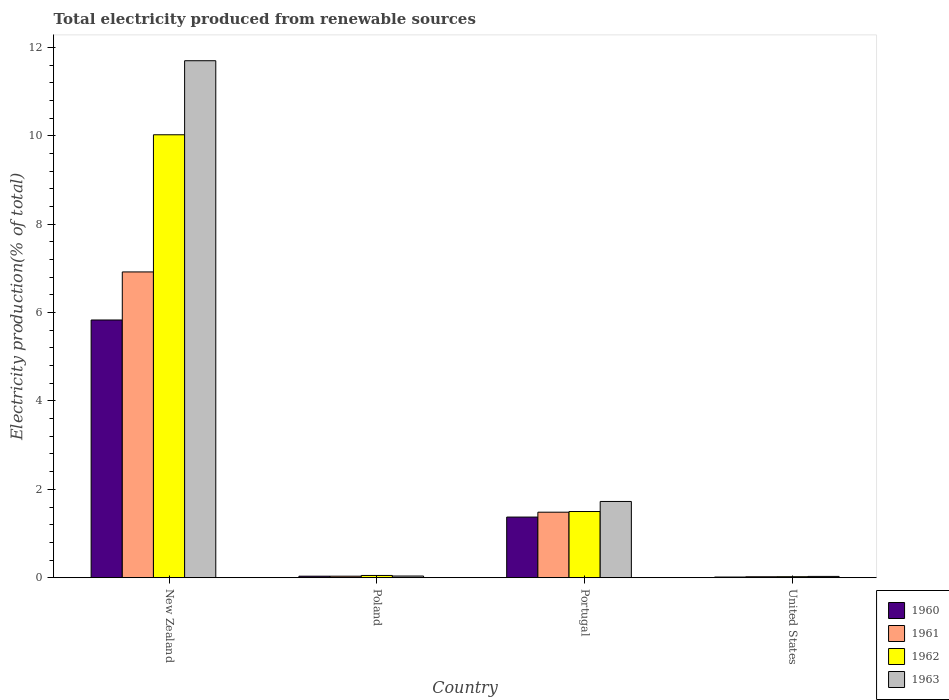How many groups of bars are there?
Offer a terse response. 4. Are the number of bars per tick equal to the number of legend labels?
Ensure brevity in your answer.  Yes. Are the number of bars on each tick of the X-axis equal?
Keep it short and to the point. Yes. How many bars are there on the 3rd tick from the left?
Provide a succinct answer. 4. How many bars are there on the 4th tick from the right?
Keep it short and to the point. 4. What is the label of the 1st group of bars from the left?
Make the answer very short. New Zealand. In how many cases, is the number of bars for a given country not equal to the number of legend labels?
Make the answer very short. 0. What is the total electricity produced in 1963 in Poland?
Your answer should be compact. 0.04. Across all countries, what is the maximum total electricity produced in 1961?
Offer a very short reply. 6.92. Across all countries, what is the minimum total electricity produced in 1962?
Give a very brief answer. 0.02. In which country was the total electricity produced in 1963 maximum?
Offer a terse response. New Zealand. What is the total total electricity produced in 1963 in the graph?
Offer a very short reply. 13.49. What is the difference between the total electricity produced in 1963 in New Zealand and that in Portugal?
Your answer should be compact. 9.97. What is the difference between the total electricity produced in 1961 in Poland and the total electricity produced in 1960 in Portugal?
Keep it short and to the point. -1.34. What is the average total electricity produced in 1963 per country?
Give a very brief answer. 3.37. What is the difference between the total electricity produced of/in 1962 and total electricity produced of/in 1960 in New Zealand?
Make the answer very short. 4.19. What is the ratio of the total electricity produced in 1960 in New Zealand to that in Portugal?
Provide a short and direct response. 4.25. Is the difference between the total electricity produced in 1962 in Portugal and United States greater than the difference between the total electricity produced in 1960 in Portugal and United States?
Ensure brevity in your answer.  Yes. What is the difference between the highest and the second highest total electricity produced in 1960?
Give a very brief answer. -1.34. What is the difference between the highest and the lowest total electricity produced in 1960?
Offer a very short reply. 5.82. In how many countries, is the total electricity produced in 1963 greater than the average total electricity produced in 1963 taken over all countries?
Keep it short and to the point. 1. Is the sum of the total electricity produced in 1960 in New Zealand and United States greater than the maximum total electricity produced in 1961 across all countries?
Your answer should be very brief. No. What does the 4th bar from the right in Poland represents?
Offer a terse response. 1960. Does the graph contain any zero values?
Your response must be concise. No. Does the graph contain grids?
Your response must be concise. No. What is the title of the graph?
Your answer should be compact. Total electricity produced from renewable sources. What is the label or title of the X-axis?
Your response must be concise. Country. What is the Electricity production(% of total) in 1960 in New Zealand?
Keep it short and to the point. 5.83. What is the Electricity production(% of total) of 1961 in New Zealand?
Your answer should be compact. 6.92. What is the Electricity production(% of total) in 1962 in New Zealand?
Your answer should be very brief. 10.02. What is the Electricity production(% of total) in 1963 in New Zealand?
Your answer should be compact. 11.7. What is the Electricity production(% of total) of 1960 in Poland?
Give a very brief answer. 0.03. What is the Electricity production(% of total) in 1961 in Poland?
Provide a succinct answer. 0.03. What is the Electricity production(% of total) of 1962 in Poland?
Provide a short and direct response. 0.05. What is the Electricity production(% of total) in 1963 in Poland?
Provide a short and direct response. 0.04. What is the Electricity production(% of total) in 1960 in Portugal?
Offer a very short reply. 1.37. What is the Electricity production(% of total) of 1961 in Portugal?
Provide a short and direct response. 1.48. What is the Electricity production(% of total) in 1962 in Portugal?
Keep it short and to the point. 1.5. What is the Electricity production(% of total) in 1963 in Portugal?
Make the answer very short. 1.73. What is the Electricity production(% of total) in 1960 in United States?
Ensure brevity in your answer.  0.02. What is the Electricity production(% of total) of 1961 in United States?
Your answer should be compact. 0.02. What is the Electricity production(% of total) in 1962 in United States?
Your response must be concise. 0.02. What is the Electricity production(% of total) of 1963 in United States?
Ensure brevity in your answer.  0.03. Across all countries, what is the maximum Electricity production(% of total) in 1960?
Your answer should be compact. 5.83. Across all countries, what is the maximum Electricity production(% of total) in 1961?
Offer a terse response. 6.92. Across all countries, what is the maximum Electricity production(% of total) in 1962?
Offer a terse response. 10.02. Across all countries, what is the maximum Electricity production(% of total) in 1963?
Make the answer very short. 11.7. Across all countries, what is the minimum Electricity production(% of total) in 1960?
Give a very brief answer. 0.02. Across all countries, what is the minimum Electricity production(% of total) of 1961?
Give a very brief answer. 0.02. Across all countries, what is the minimum Electricity production(% of total) in 1962?
Offer a terse response. 0.02. Across all countries, what is the minimum Electricity production(% of total) of 1963?
Your answer should be very brief. 0.03. What is the total Electricity production(% of total) in 1960 in the graph?
Make the answer very short. 7.25. What is the total Electricity production(% of total) in 1961 in the graph?
Ensure brevity in your answer.  8.46. What is the total Electricity production(% of total) in 1962 in the graph?
Keep it short and to the point. 11.6. What is the total Electricity production(% of total) in 1963 in the graph?
Offer a very short reply. 13.49. What is the difference between the Electricity production(% of total) in 1960 in New Zealand and that in Poland?
Your response must be concise. 5.8. What is the difference between the Electricity production(% of total) in 1961 in New Zealand and that in Poland?
Give a very brief answer. 6.89. What is the difference between the Electricity production(% of total) in 1962 in New Zealand and that in Poland?
Your answer should be compact. 9.97. What is the difference between the Electricity production(% of total) of 1963 in New Zealand and that in Poland?
Ensure brevity in your answer.  11.66. What is the difference between the Electricity production(% of total) of 1960 in New Zealand and that in Portugal?
Provide a succinct answer. 4.46. What is the difference between the Electricity production(% of total) in 1961 in New Zealand and that in Portugal?
Keep it short and to the point. 5.44. What is the difference between the Electricity production(% of total) of 1962 in New Zealand and that in Portugal?
Your response must be concise. 8.53. What is the difference between the Electricity production(% of total) of 1963 in New Zealand and that in Portugal?
Keep it short and to the point. 9.97. What is the difference between the Electricity production(% of total) in 1960 in New Zealand and that in United States?
Give a very brief answer. 5.82. What is the difference between the Electricity production(% of total) in 1961 in New Zealand and that in United States?
Your answer should be very brief. 6.9. What is the difference between the Electricity production(% of total) of 1962 in New Zealand and that in United States?
Provide a succinct answer. 10. What is the difference between the Electricity production(% of total) in 1963 in New Zealand and that in United States?
Make the answer very short. 11.67. What is the difference between the Electricity production(% of total) in 1960 in Poland and that in Portugal?
Provide a short and direct response. -1.34. What is the difference between the Electricity production(% of total) in 1961 in Poland and that in Portugal?
Provide a succinct answer. -1.45. What is the difference between the Electricity production(% of total) in 1962 in Poland and that in Portugal?
Offer a terse response. -1.45. What is the difference between the Electricity production(% of total) of 1963 in Poland and that in Portugal?
Provide a short and direct response. -1.69. What is the difference between the Electricity production(% of total) of 1960 in Poland and that in United States?
Your response must be concise. 0.02. What is the difference between the Electricity production(% of total) of 1961 in Poland and that in United States?
Ensure brevity in your answer.  0.01. What is the difference between the Electricity production(% of total) of 1962 in Poland and that in United States?
Your answer should be very brief. 0.03. What is the difference between the Electricity production(% of total) of 1963 in Poland and that in United States?
Provide a short and direct response. 0.01. What is the difference between the Electricity production(% of total) in 1960 in Portugal and that in United States?
Keep it short and to the point. 1.36. What is the difference between the Electricity production(% of total) in 1961 in Portugal and that in United States?
Your answer should be compact. 1.46. What is the difference between the Electricity production(% of total) in 1962 in Portugal and that in United States?
Make the answer very short. 1.48. What is the difference between the Electricity production(% of total) in 1963 in Portugal and that in United States?
Offer a terse response. 1.7. What is the difference between the Electricity production(% of total) of 1960 in New Zealand and the Electricity production(% of total) of 1961 in Poland?
Give a very brief answer. 5.8. What is the difference between the Electricity production(% of total) of 1960 in New Zealand and the Electricity production(% of total) of 1962 in Poland?
Make the answer very short. 5.78. What is the difference between the Electricity production(% of total) of 1960 in New Zealand and the Electricity production(% of total) of 1963 in Poland?
Offer a terse response. 5.79. What is the difference between the Electricity production(% of total) of 1961 in New Zealand and the Electricity production(% of total) of 1962 in Poland?
Provide a succinct answer. 6.87. What is the difference between the Electricity production(% of total) of 1961 in New Zealand and the Electricity production(% of total) of 1963 in Poland?
Keep it short and to the point. 6.88. What is the difference between the Electricity production(% of total) in 1962 in New Zealand and the Electricity production(% of total) in 1963 in Poland?
Ensure brevity in your answer.  9.99. What is the difference between the Electricity production(% of total) of 1960 in New Zealand and the Electricity production(% of total) of 1961 in Portugal?
Your answer should be compact. 4.35. What is the difference between the Electricity production(% of total) of 1960 in New Zealand and the Electricity production(% of total) of 1962 in Portugal?
Make the answer very short. 4.33. What is the difference between the Electricity production(% of total) in 1960 in New Zealand and the Electricity production(% of total) in 1963 in Portugal?
Provide a succinct answer. 4.11. What is the difference between the Electricity production(% of total) in 1961 in New Zealand and the Electricity production(% of total) in 1962 in Portugal?
Ensure brevity in your answer.  5.42. What is the difference between the Electricity production(% of total) of 1961 in New Zealand and the Electricity production(% of total) of 1963 in Portugal?
Your answer should be very brief. 5.19. What is the difference between the Electricity production(% of total) in 1962 in New Zealand and the Electricity production(% of total) in 1963 in Portugal?
Ensure brevity in your answer.  8.3. What is the difference between the Electricity production(% of total) of 1960 in New Zealand and the Electricity production(% of total) of 1961 in United States?
Offer a very short reply. 5.81. What is the difference between the Electricity production(% of total) in 1960 in New Zealand and the Electricity production(% of total) in 1962 in United States?
Give a very brief answer. 5.81. What is the difference between the Electricity production(% of total) in 1960 in New Zealand and the Electricity production(% of total) in 1963 in United States?
Provide a short and direct response. 5.8. What is the difference between the Electricity production(% of total) in 1961 in New Zealand and the Electricity production(% of total) in 1962 in United States?
Ensure brevity in your answer.  6.9. What is the difference between the Electricity production(% of total) of 1961 in New Zealand and the Electricity production(% of total) of 1963 in United States?
Offer a very short reply. 6.89. What is the difference between the Electricity production(% of total) of 1962 in New Zealand and the Electricity production(% of total) of 1963 in United States?
Your response must be concise. 10. What is the difference between the Electricity production(% of total) in 1960 in Poland and the Electricity production(% of total) in 1961 in Portugal?
Your answer should be very brief. -1.45. What is the difference between the Electricity production(% of total) of 1960 in Poland and the Electricity production(% of total) of 1962 in Portugal?
Your answer should be compact. -1.46. What is the difference between the Electricity production(% of total) of 1960 in Poland and the Electricity production(% of total) of 1963 in Portugal?
Provide a short and direct response. -1.69. What is the difference between the Electricity production(% of total) of 1961 in Poland and the Electricity production(% of total) of 1962 in Portugal?
Make the answer very short. -1.46. What is the difference between the Electricity production(% of total) of 1961 in Poland and the Electricity production(% of total) of 1963 in Portugal?
Ensure brevity in your answer.  -1.69. What is the difference between the Electricity production(% of total) in 1962 in Poland and the Electricity production(% of total) in 1963 in Portugal?
Provide a succinct answer. -1.67. What is the difference between the Electricity production(% of total) of 1960 in Poland and the Electricity production(% of total) of 1961 in United States?
Keep it short and to the point. 0.01. What is the difference between the Electricity production(% of total) of 1960 in Poland and the Electricity production(% of total) of 1962 in United States?
Your answer should be compact. 0.01. What is the difference between the Electricity production(% of total) in 1960 in Poland and the Electricity production(% of total) in 1963 in United States?
Your answer should be very brief. 0. What is the difference between the Electricity production(% of total) of 1961 in Poland and the Electricity production(% of total) of 1962 in United States?
Provide a short and direct response. 0.01. What is the difference between the Electricity production(% of total) of 1961 in Poland and the Electricity production(% of total) of 1963 in United States?
Provide a short and direct response. 0. What is the difference between the Electricity production(% of total) of 1962 in Poland and the Electricity production(% of total) of 1963 in United States?
Give a very brief answer. 0.02. What is the difference between the Electricity production(% of total) in 1960 in Portugal and the Electricity production(% of total) in 1961 in United States?
Give a very brief answer. 1.35. What is the difference between the Electricity production(% of total) of 1960 in Portugal and the Electricity production(% of total) of 1962 in United States?
Provide a succinct answer. 1.35. What is the difference between the Electricity production(% of total) of 1960 in Portugal and the Electricity production(% of total) of 1963 in United States?
Give a very brief answer. 1.34. What is the difference between the Electricity production(% of total) of 1961 in Portugal and the Electricity production(% of total) of 1962 in United States?
Offer a terse response. 1.46. What is the difference between the Electricity production(% of total) in 1961 in Portugal and the Electricity production(% of total) in 1963 in United States?
Keep it short and to the point. 1.45. What is the difference between the Electricity production(% of total) in 1962 in Portugal and the Electricity production(% of total) in 1963 in United States?
Give a very brief answer. 1.47. What is the average Electricity production(% of total) of 1960 per country?
Ensure brevity in your answer.  1.81. What is the average Electricity production(% of total) in 1961 per country?
Provide a succinct answer. 2.11. What is the average Electricity production(% of total) in 1962 per country?
Make the answer very short. 2.9. What is the average Electricity production(% of total) in 1963 per country?
Your answer should be compact. 3.37. What is the difference between the Electricity production(% of total) in 1960 and Electricity production(% of total) in 1961 in New Zealand?
Offer a terse response. -1.09. What is the difference between the Electricity production(% of total) in 1960 and Electricity production(% of total) in 1962 in New Zealand?
Your answer should be very brief. -4.19. What is the difference between the Electricity production(% of total) in 1960 and Electricity production(% of total) in 1963 in New Zealand?
Make the answer very short. -5.87. What is the difference between the Electricity production(% of total) in 1961 and Electricity production(% of total) in 1962 in New Zealand?
Your response must be concise. -3.1. What is the difference between the Electricity production(% of total) in 1961 and Electricity production(% of total) in 1963 in New Zealand?
Provide a short and direct response. -4.78. What is the difference between the Electricity production(% of total) of 1962 and Electricity production(% of total) of 1963 in New Zealand?
Provide a short and direct response. -1.68. What is the difference between the Electricity production(% of total) of 1960 and Electricity production(% of total) of 1962 in Poland?
Make the answer very short. -0.02. What is the difference between the Electricity production(% of total) in 1960 and Electricity production(% of total) in 1963 in Poland?
Provide a short and direct response. -0. What is the difference between the Electricity production(% of total) in 1961 and Electricity production(% of total) in 1962 in Poland?
Your answer should be very brief. -0.02. What is the difference between the Electricity production(% of total) of 1961 and Electricity production(% of total) of 1963 in Poland?
Your answer should be very brief. -0. What is the difference between the Electricity production(% of total) of 1962 and Electricity production(% of total) of 1963 in Poland?
Make the answer very short. 0.01. What is the difference between the Electricity production(% of total) in 1960 and Electricity production(% of total) in 1961 in Portugal?
Provide a short and direct response. -0.11. What is the difference between the Electricity production(% of total) of 1960 and Electricity production(% of total) of 1962 in Portugal?
Keep it short and to the point. -0.13. What is the difference between the Electricity production(% of total) of 1960 and Electricity production(% of total) of 1963 in Portugal?
Provide a short and direct response. -0.35. What is the difference between the Electricity production(% of total) of 1961 and Electricity production(% of total) of 1962 in Portugal?
Make the answer very short. -0.02. What is the difference between the Electricity production(% of total) in 1961 and Electricity production(% of total) in 1963 in Portugal?
Keep it short and to the point. -0.24. What is the difference between the Electricity production(% of total) of 1962 and Electricity production(% of total) of 1963 in Portugal?
Make the answer very short. -0.23. What is the difference between the Electricity production(% of total) of 1960 and Electricity production(% of total) of 1961 in United States?
Your answer should be very brief. -0.01. What is the difference between the Electricity production(% of total) in 1960 and Electricity production(% of total) in 1962 in United States?
Ensure brevity in your answer.  -0.01. What is the difference between the Electricity production(% of total) in 1960 and Electricity production(% of total) in 1963 in United States?
Provide a short and direct response. -0.01. What is the difference between the Electricity production(% of total) in 1961 and Electricity production(% of total) in 1962 in United States?
Keep it short and to the point. -0. What is the difference between the Electricity production(% of total) in 1961 and Electricity production(% of total) in 1963 in United States?
Provide a short and direct response. -0.01. What is the difference between the Electricity production(% of total) in 1962 and Electricity production(% of total) in 1963 in United States?
Offer a very short reply. -0.01. What is the ratio of the Electricity production(% of total) of 1960 in New Zealand to that in Poland?
Offer a very short reply. 170.79. What is the ratio of the Electricity production(% of total) of 1961 in New Zealand to that in Poland?
Provide a short and direct response. 202.83. What is the ratio of the Electricity production(% of total) of 1962 in New Zealand to that in Poland?
Provide a succinct answer. 196.95. What is the ratio of the Electricity production(% of total) in 1963 in New Zealand to that in Poland?
Your answer should be very brief. 308.73. What is the ratio of the Electricity production(% of total) in 1960 in New Zealand to that in Portugal?
Make the answer very short. 4.25. What is the ratio of the Electricity production(% of total) in 1961 in New Zealand to that in Portugal?
Provide a short and direct response. 4.67. What is the ratio of the Electricity production(% of total) of 1962 in New Zealand to that in Portugal?
Offer a very short reply. 6.69. What is the ratio of the Electricity production(% of total) of 1963 in New Zealand to that in Portugal?
Your answer should be compact. 6.78. What is the ratio of the Electricity production(% of total) of 1960 in New Zealand to that in United States?
Your response must be concise. 382.31. What is the ratio of the Electricity production(% of total) of 1961 in New Zealand to that in United States?
Offer a terse response. 321.25. What is the ratio of the Electricity production(% of total) in 1962 in New Zealand to that in United States?
Provide a short and direct response. 439.93. What is the ratio of the Electricity production(% of total) in 1963 in New Zealand to that in United States?
Your answer should be very brief. 397.5. What is the ratio of the Electricity production(% of total) of 1960 in Poland to that in Portugal?
Keep it short and to the point. 0.02. What is the ratio of the Electricity production(% of total) of 1961 in Poland to that in Portugal?
Your answer should be very brief. 0.02. What is the ratio of the Electricity production(% of total) in 1962 in Poland to that in Portugal?
Offer a very short reply. 0.03. What is the ratio of the Electricity production(% of total) in 1963 in Poland to that in Portugal?
Ensure brevity in your answer.  0.02. What is the ratio of the Electricity production(% of total) in 1960 in Poland to that in United States?
Provide a succinct answer. 2.24. What is the ratio of the Electricity production(% of total) of 1961 in Poland to that in United States?
Give a very brief answer. 1.58. What is the ratio of the Electricity production(% of total) in 1962 in Poland to that in United States?
Provide a succinct answer. 2.23. What is the ratio of the Electricity production(% of total) of 1963 in Poland to that in United States?
Provide a short and direct response. 1.29. What is the ratio of the Electricity production(% of total) in 1960 in Portugal to that in United States?
Your answer should be very brief. 89.96. What is the ratio of the Electricity production(% of total) in 1961 in Portugal to that in United States?
Provide a short and direct response. 68.83. What is the ratio of the Electricity production(% of total) of 1962 in Portugal to that in United States?
Your response must be concise. 65.74. What is the ratio of the Electricity production(% of total) of 1963 in Portugal to that in United States?
Your answer should be very brief. 58.63. What is the difference between the highest and the second highest Electricity production(% of total) in 1960?
Ensure brevity in your answer.  4.46. What is the difference between the highest and the second highest Electricity production(% of total) of 1961?
Ensure brevity in your answer.  5.44. What is the difference between the highest and the second highest Electricity production(% of total) of 1962?
Give a very brief answer. 8.53. What is the difference between the highest and the second highest Electricity production(% of total) in 1963?
Ensure brevity in your answer.  9.97. What is the difference between the highest and the lowest Electricity production(% of total) in 1960?
Your response must be concise. 5.82. What is the difference between the highest and the lowest Electricity production(% of total) of 1961?
Ensure brevity in your answer.  6.9. What is the difference between the highest and the lowest Electricity production(% of total) of 1962?
Your answer should be very brief. 10. What is the difference between the highest and the lowest Electricity production(% of total) in 1963?
Your response must be concise. 11.67. 